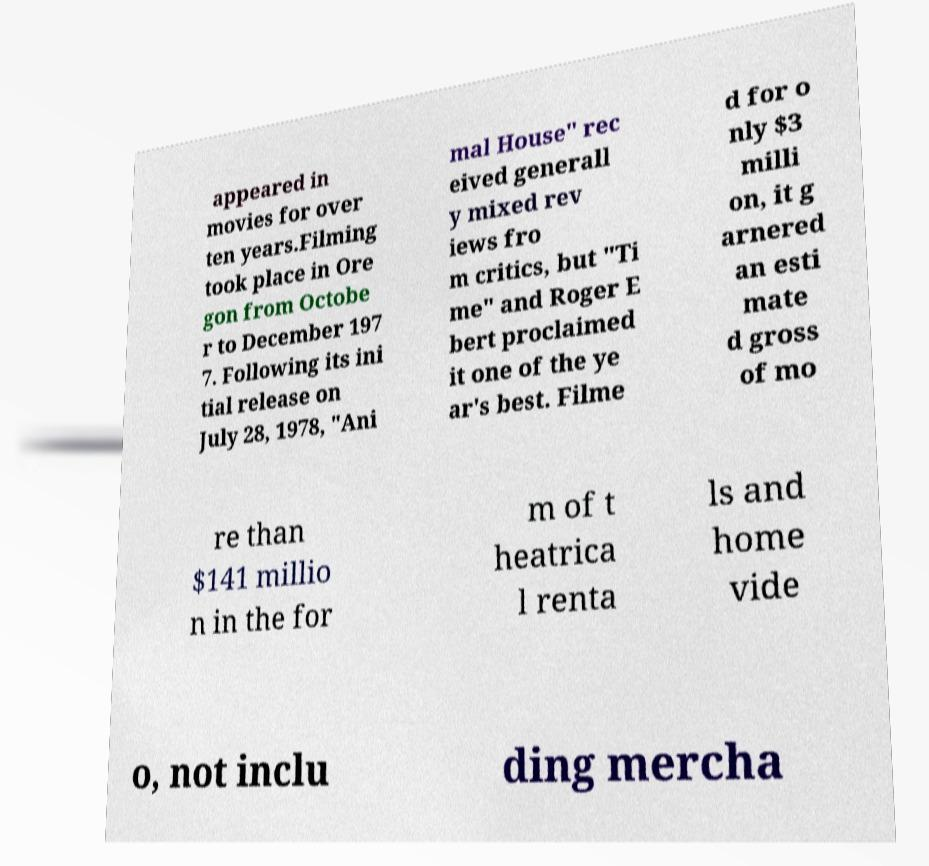Please identify and transcribe the text found in this image. appeared in movies for over ten years.Filming took place in Ore gon from Octobe r to December 197 7. Following its ini tial release on July 28, 1978, "Ani mal House" rec eived generall y mixed rev iews fro m critics, but "Ti me" and Roger E bert proclaimed it one of the ye ar's best. Filme d for o nly $3 milli on, it g arnered an esti mate d gross of mo re than $141 millio n in the for m of t heatrica l renta ls and home vide o, not inclu ding mercha 